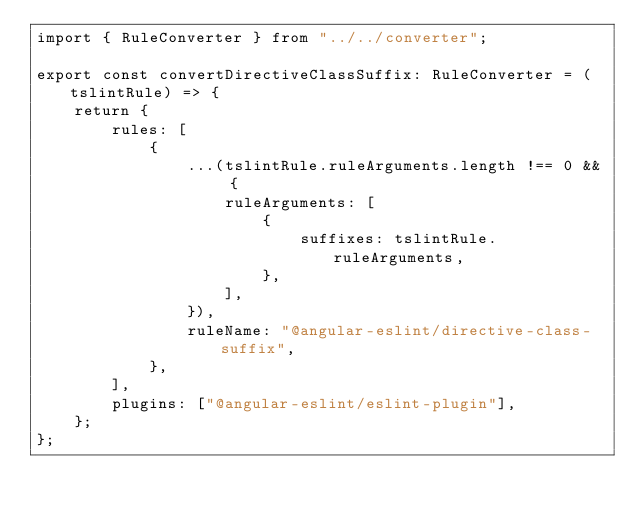<code> <loc_0><loc_0><loc_500><loc_500><_TypeScript_>import { RuleConverter } from "../../converter";

export const convertDirectiveClassSuffix: RuleConverter = (tslintRule) => {
    return {
        rules: [
            {
                ...(tslintRule.ruleArguments.length !== 0 && {
                    ruleArguments: [
                        {
                            suffixes: tslintRule.ruleArguments,
                        },
                    ],
                }),
                ruleName: "@angular-eslint/directive-class-suffix",
            },
        ],
        plugins: ["@angular-eslint/eslint-plugin"],
    };
};
</code> 